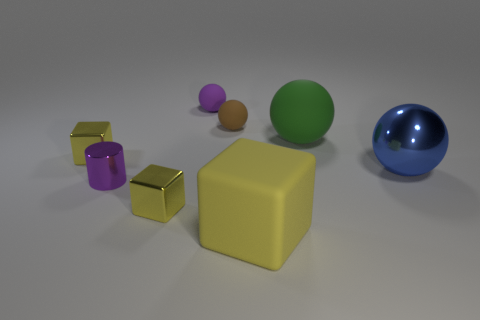Add 1 big green balls. How many objects exist? 9 Subtract all cylinders. How many objects are left? 7 Subtract 1 purple cylinders. How many objects are left? 7 Subtract all tiny blue rubber things. Subtract all small brown things. How many objects are left? 7 Add 6 large cubes. How many large cubes are left? 7 Add 7 small green matte cubes. How many small green matte cubes exist? 7 